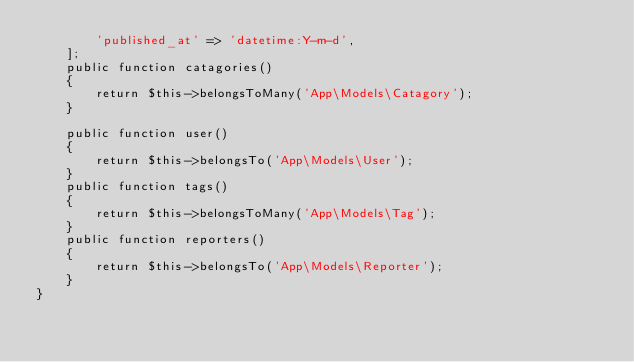Convert code to text. <code><loc_0><loc_0><loc_500><loc_500><_PHP_>        'published_at' => 'datetime:Y-m-d',
    ];
    public function catagories()
    {
        return $this->belongsToMany('App\Models\Catagory');
    }

    public function user()
    {
        return $this->belongsTo('App\Models\User');
    }
    public function tags()
    {
        return $this->belongsToMany('App\Models\Tag');
    }
    public function reporters()
    {
        return $this->belongsTo('App\Models\Reporter');
    }
}
</code> 